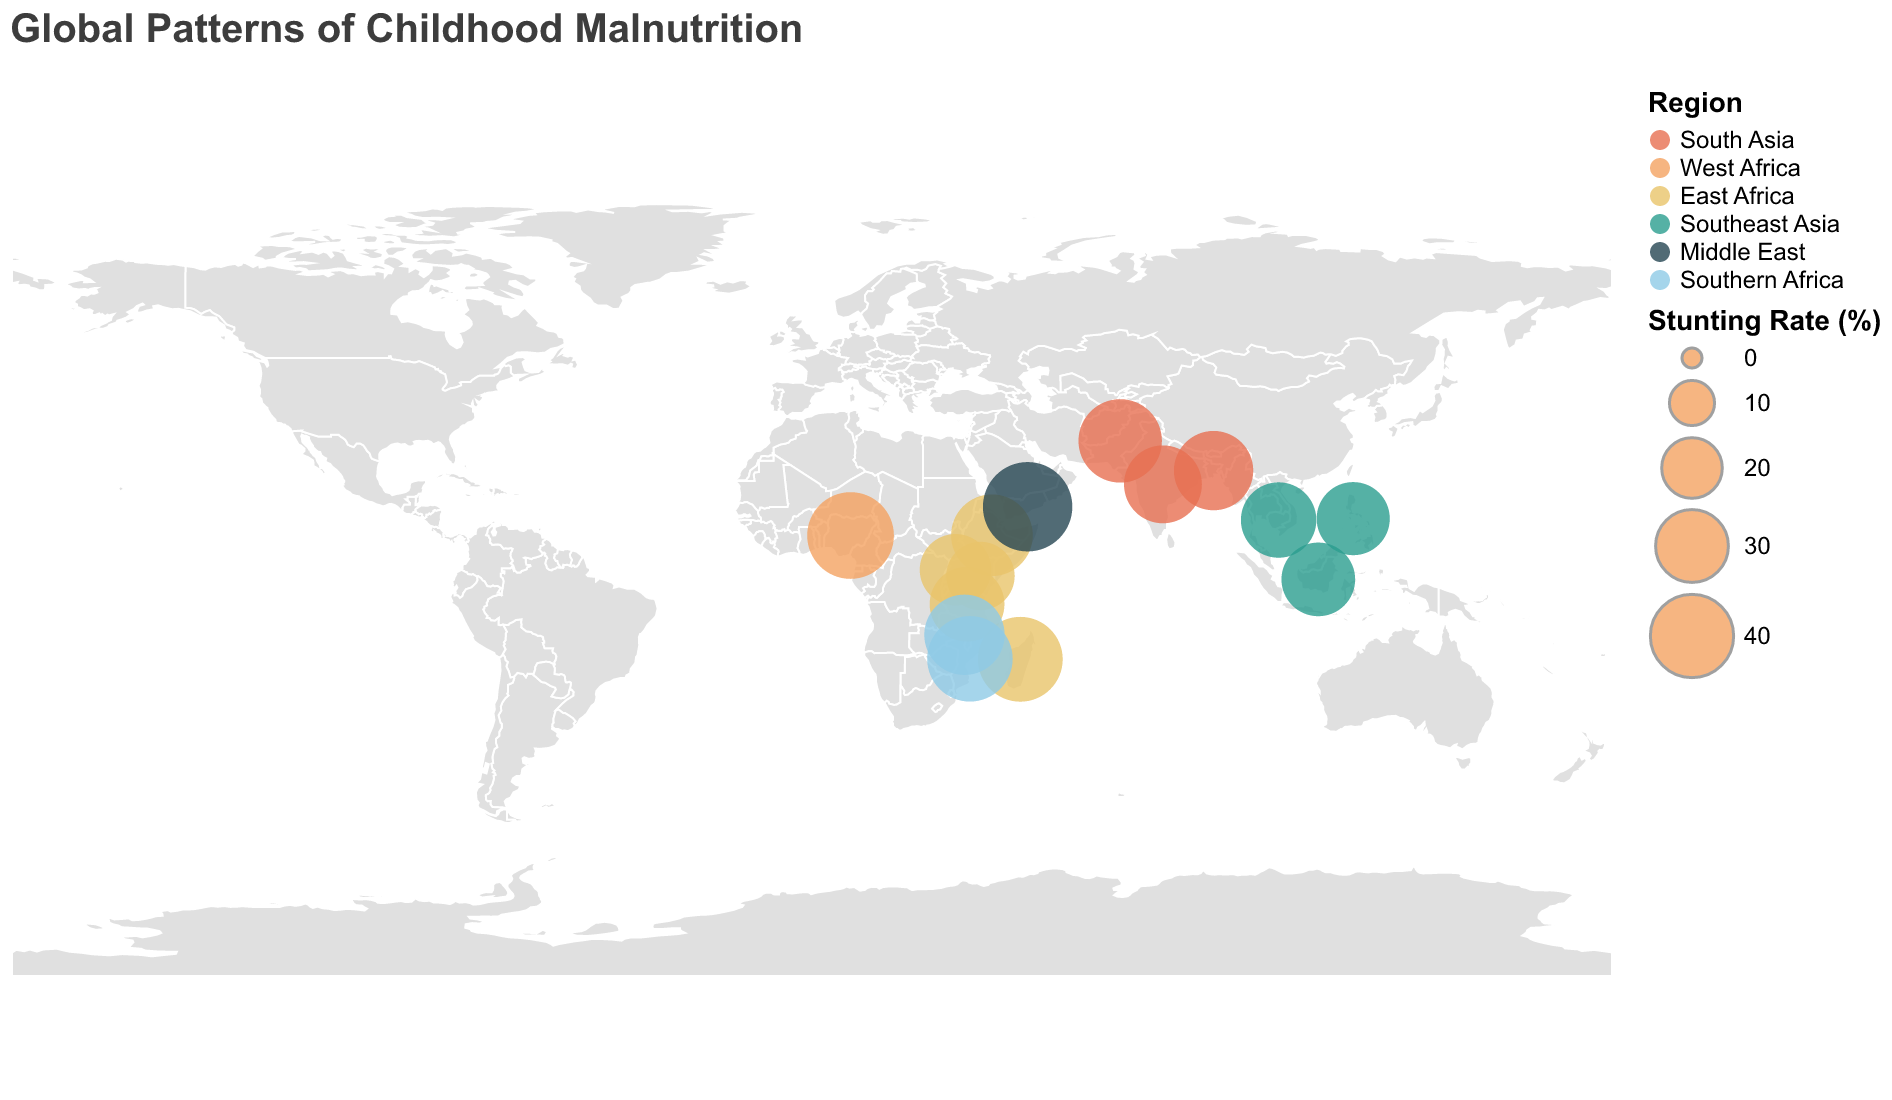What is the stunting rate in Yemen? The stunting rate in Yemen is directly provided in the tooltip, which indicates the rate of stunting for each country.
Answer: 46.5% Which region has the highest stunting rate on average? The regions and their respective stunting rates need to be calculated and averaged: South Asia (34.7, 40.2, 36.1), West Africa (43.6), East Africa (38.4, 31.8, 26.2, 28.9, 41.6), Southeast Asia (30.8, 30.3, 32.4), Middle East (46.5), Southern Africa (42.3, 37.1). Calculate the average for each region and compare.
Answer: Middle East How does the underweight rate in Tanzania compare to Uganda? Check the underweight rates of Tanzania and Uganda from the tooltips: Tanzania (13.7%), Uganda (10.4%). Tanzania's underweight rate is higher than Uganda's.
Answer: Higher List the countries in Southeast Asia included in the plot. From the color legend and the map, identify the countries marked with the color representing Southeast Asia (30.8, 10.2, 17.7; 30.3, 5.6, 19.1; 32.4, 9.6, 24.1). The countries are Indonesia, Philippines, and Cambodia.
Answer: Indonesia, Philippines, Cambodia What is the difference in wasting rates between Pakistan and Bangladesh? From the tooltips: Wasting rate of Pakistan (17.7%), Bangladesh (14.3%). Calculate the difference: 17.7 - 14.3.
Answer: 3.4% Which country in South Asia has the highest stunting rate? Compare stunting rates of South Asian countries from the tooltips: India (34.7%), Pakistan (40.2%), Bangladesh (36.1%). Pakistan has the highest rate.
Answer: Pakistan Identify the region with the least number of countries represented in the plot. Count the number of countries in each region: South Asia (3), West Africa (1), East Africa (5), Southeast Asia (3), Middle East (1), Southern Africa (2). West Africa and Middle East have the least, with 1 country each.
Answer: West Africa, Middle East What percentage of stunting rate does Mozambique have? Identify Mozambique from the color legend and tooltip, showing the stunting rate as 42.3%.
Answer: 42.3% Which country has the lowest stunting rate in the Middle East region? There is only one country from the Middle East in the plot, which is Yemen with a stunting rate of 46.5%.
Answer: Yemen Out of the countries identified, which has the highest wasting rate? Check all wasting rates from the tooltips and find the highest: Yemen (16.3%), Pakistan (17.7%), Indonesia (10.2%), Madagascar (6.4%), Mozambique (6.1%), Cambodia (9.6%), Nigeria (10.8%), Ethiopia (7.2%), Philippines (5.6%), Tanzania (3.5%), Kenya (4.2%), Uganda (3.5%), Bangladesh (14.3%), Malawi (2.7%). The highest is Pakistan's wasting rate.
Answer: Pakistan 